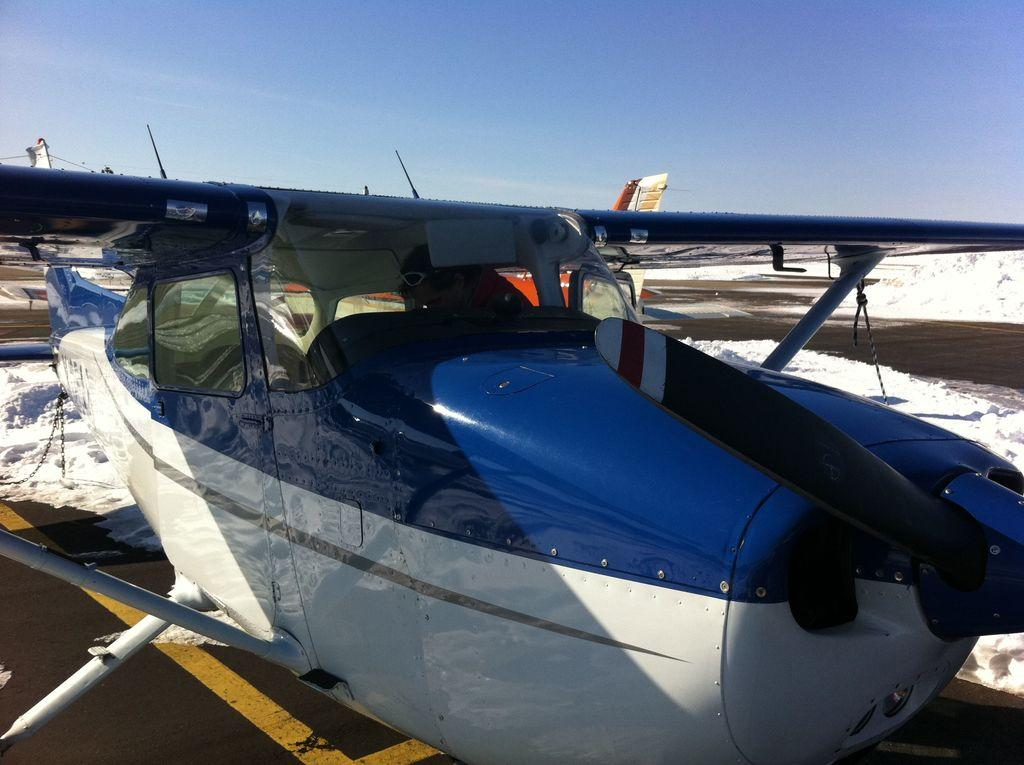What is the main subject of the image? The main subject of the image is a flying jet. Can you describe the person inside the jet? A person wearing goggles is visible inside the jet. What else can be seen in the image besides the jet? There is a road and snow present in the image. What is visible in the background of the image? The sky is visible in the image. What type of suggestion is being made by the person in the middle of the image? There is no person in the middle of the image; the main subject is the flying jet. What place is depicted in the image? The image does not depict a specific place; it shows a flying jet, a road, snow, and the sky. 